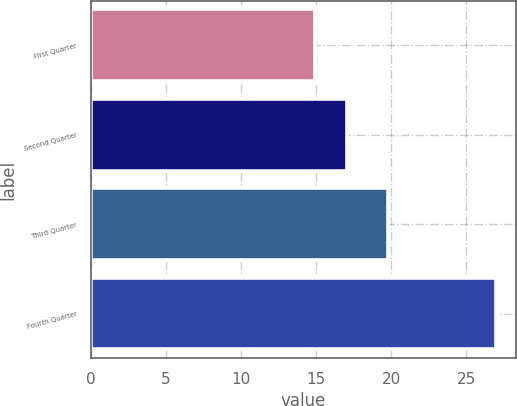Convert chart to OTSL. <chart><loc_0><loc_0><loc_500><loc_500><bar_chart><fcel>First Quarter<fcel>Second Quarter<fcel>Third Quarter<fcel>Fourth Quarter<nl><fcel>14.93<fcel>17.07<fcel>19.79<fcel>26.94<nl></chart> 